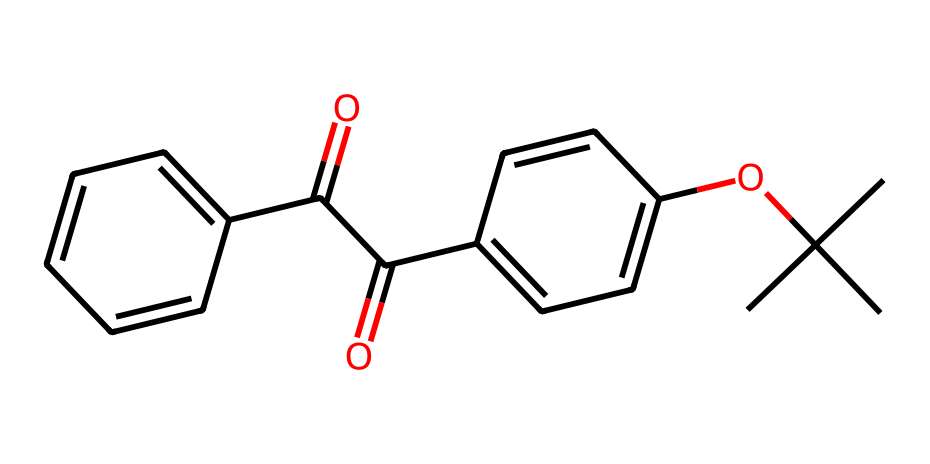What is the total number of carbon atoms in this chemical? By examining the SMILES representation, we can count the number of 'C' symbols that represent carbon atoms. In the provided structure, there are 18 individual 'C' characters present.
Answer: 18 How many double bonds are present in this chemical? In the SMILES representation, a double bond is indicated by the '=' symbol. Counting the '=' signs in the chemical structure gives us a total of 4 double bonds.
Answer: 4 What type of chemical group is indicated by 'O=C'? The 'O=C' fragment indicates a carbonyl group, which implies there is a carbon atom double-bonded to an oxygen atom. This is a characteristic feature of ketones and aldehydes.
Answer: carbonyl group What is the significance of the 'C(C)(C)' part in the chemical? The 'C(C)(C)' indicates that there is a tertiary carbon, meaning that this carbon is bonded to three other carbons (this is significant in terms of stability and reactivity in hydrocarbons).
Answer: tertiary carbon What is the main use of this chemical in sunscreen? The chemical structure is consistent with a compound that likely acts as a UV filter, providing protection from harmful ultraviolet radiation.
Answer: UV filter Which part of the chemical indicates aromatic properties? The presence of the 'C1=CC=C(C=C1)' indicates a benzene ring, which is characteristic of aromatic compounds. This imparts stability and unique chemical properties.
Answer: benzene ring 